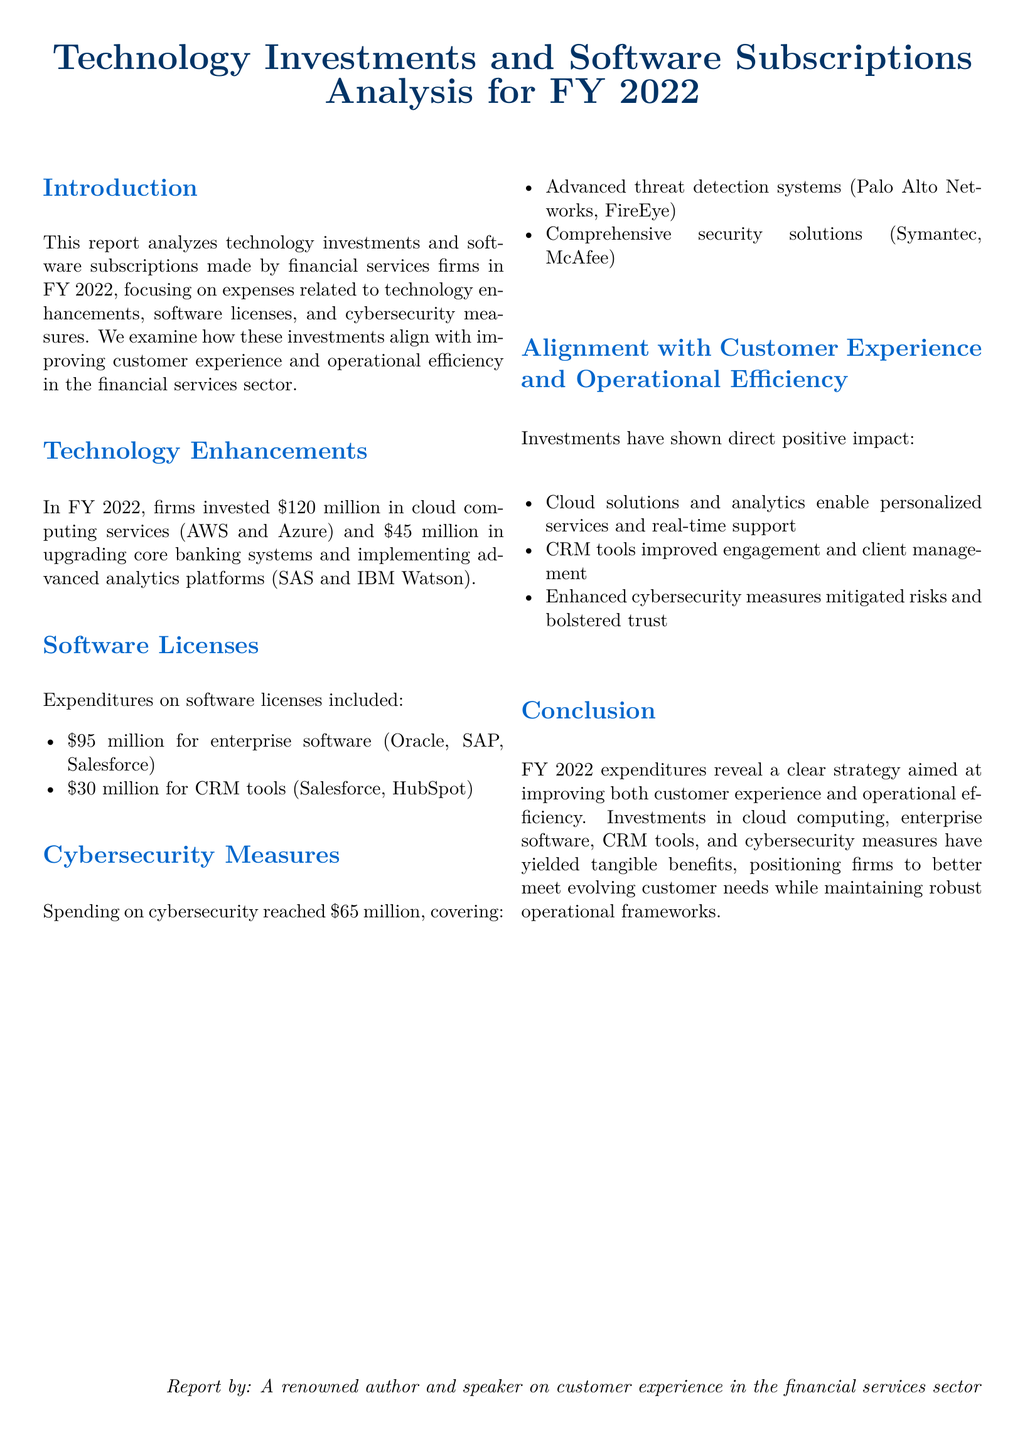What was the total investment in cloud computing services? The document states that firms invested $120 million in cloud computing services in FY 2022.
Answer: $120 million How much was spent on upgrading core banking systems? The report specifies $45 million was spent on upgrading core banking systems.
Answer: $45 million What was the expenditure on enterprise software licenses? The document indicates expenditures included $95 million for enterprise software licenses.
Answer: $95 million What is the total expenditure on cybersecurity measures? According to the report, spending on cybersecurity reached $65 million.
Answer: $65 million Which software platform is mentioned for advanced analytics? The document mentions SAS and IBM Watson as advanced analytics platforms.
Answer: SAS and IBM Watson What impact did cloud solutions have according to the report? The report indicates that cloud solutions enable personalized services and real-time support.
Answer: Personalized services and real-time support How much was invested in CRM tools? The report states that $30 million was invested in CRM tools.
Answer: $30 million What is a noted benefit of enhanced cybersecurity measures? The document highlights that enhanced cybersecurity measures mitigated risks and bolstered trust.
Answer: Mitigated risks and bolstered trust What financial year does the report cover? The document specifies that the analysis is for FY 2022.
Answer: FY 2022 